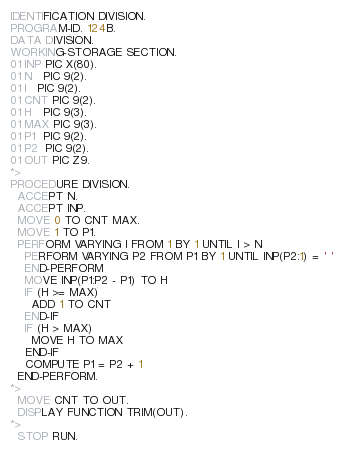Convert code to text. <code><loc_0><loc_0><loc_500><loc_500><_COBOL_>IDENTIFICATION DIVISION.
PROGRAM-ID. 124B.
DATA DIVISION.
WORKING-STORAGE SECTION.
01 INP PIC X(80).
01 N   PIC 9(2).
01 I   PIC 9(2).
01 CNT PIC 9(2).
01 H   PIC 9(3).
01 MAX PIC 9(3).
01 P1  PIC 9(2).
01 P2  PIC 9(2).
01 OUT PIC Z9.
*>
PROCEDURE DIVISION.
  ACCEPT N.
  ACCEPT INP.
  MOVE 0 TO CNT MAX.
  MOVE 1 TO P1.
  PERFORM VARYING I FROM 1 BY 1 UNTIL I > N
    PERFORM VARYING P2 FROM P1 BY 1 UNTIL INP(P2:1) = ' '
    END-PERFORM
    MOVE INP(P1:P2 - P1) TO H
    IF (H >= MAX)
      ADD 1 TO CNT
    END-IF
    IF (H > MAX)
      MOVE H TO MAX
    END-IF
    COMPUTE P1 = P2 + 1
  END-PERFORM.
*>
  MOVE CNT TO OUT.
  DISPLAY FUNCTION TRIM(OUT).
*>
  STOP RUN.
</code> 